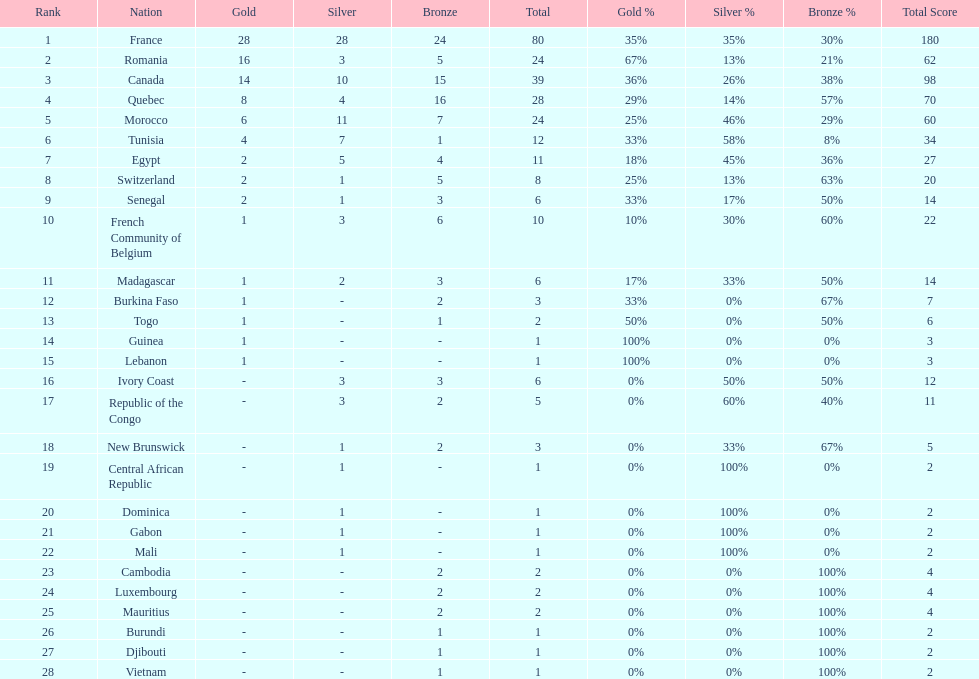How many more medals did egypt win than ivory coast? 5. 